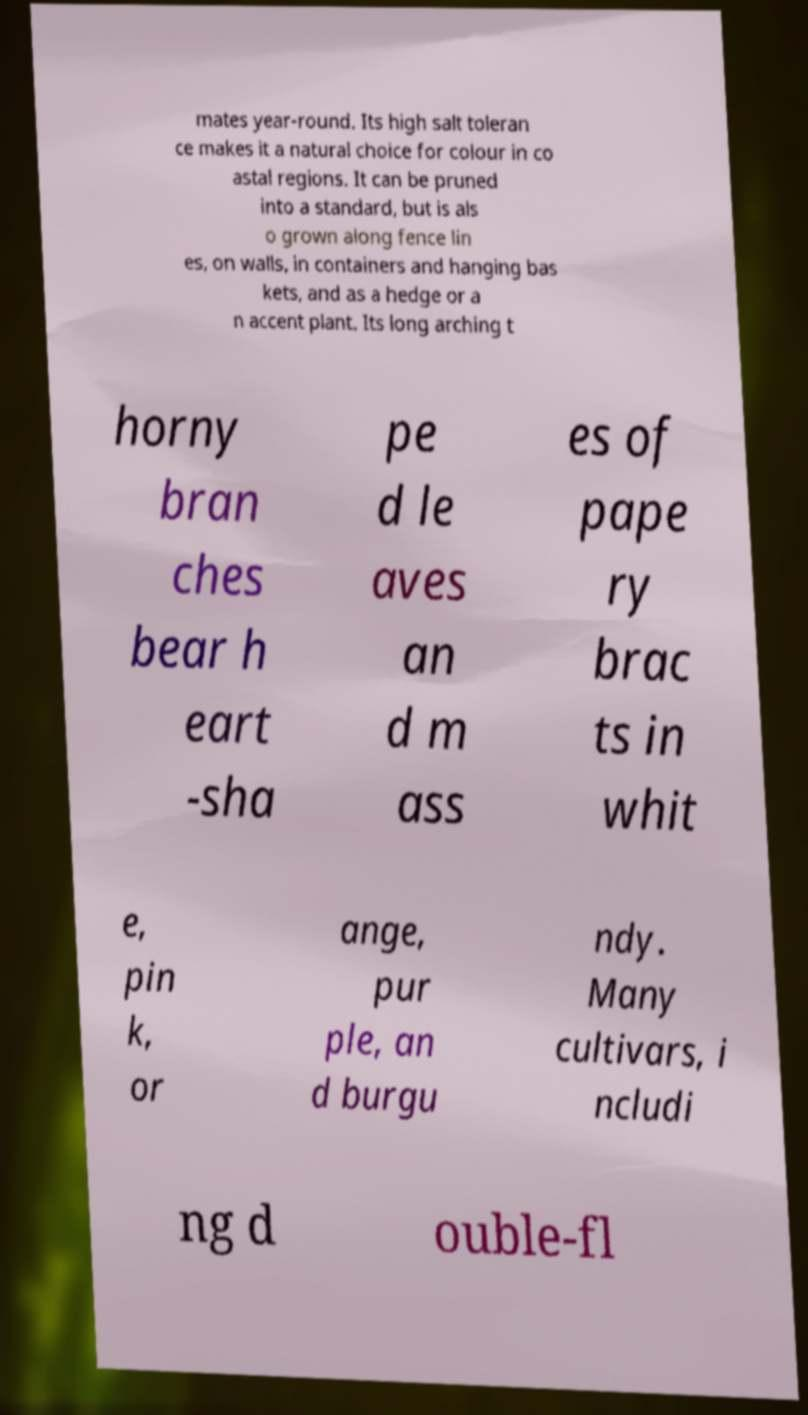Please read and relay the text visible in this image. What does it say? mates year-round. Its high salt toleran ce makes it a natural choice for colour in co astal regions. It can be pruned into a standard, but is als o grown along fence lin es, on walls, in containers and hanging bas kets, and as a hedge or a n accent plant. Its long arching t horny bran ches bear h eart -sha pe d le aves an d m ass es of pape ry brac ts in whit e, pin k, or ange, pur ple, an d burgu ndy. Many cultivars, i ncludi ng d ouble-fl 